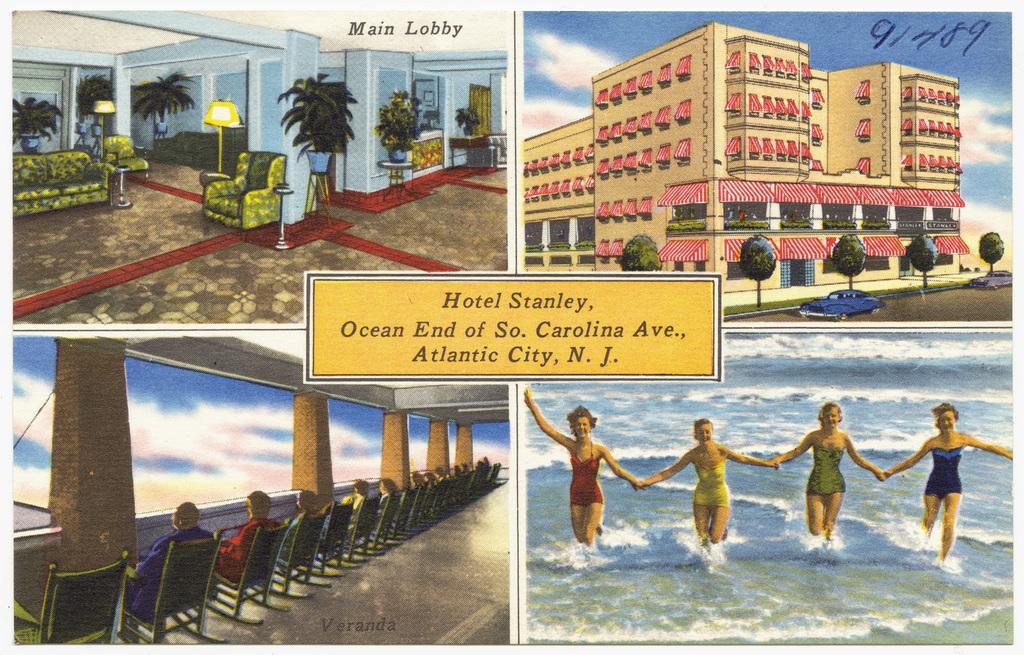In one or two sentences, can you explain what this image depicts? In this image, we can see a collage image of four different pictures. In the first one, we can see there is an inside view of a building. In the second one, there is a building. In the third one, we can see some persons sitting on chairs. In the fourth one, we can see four persons in the beach. 